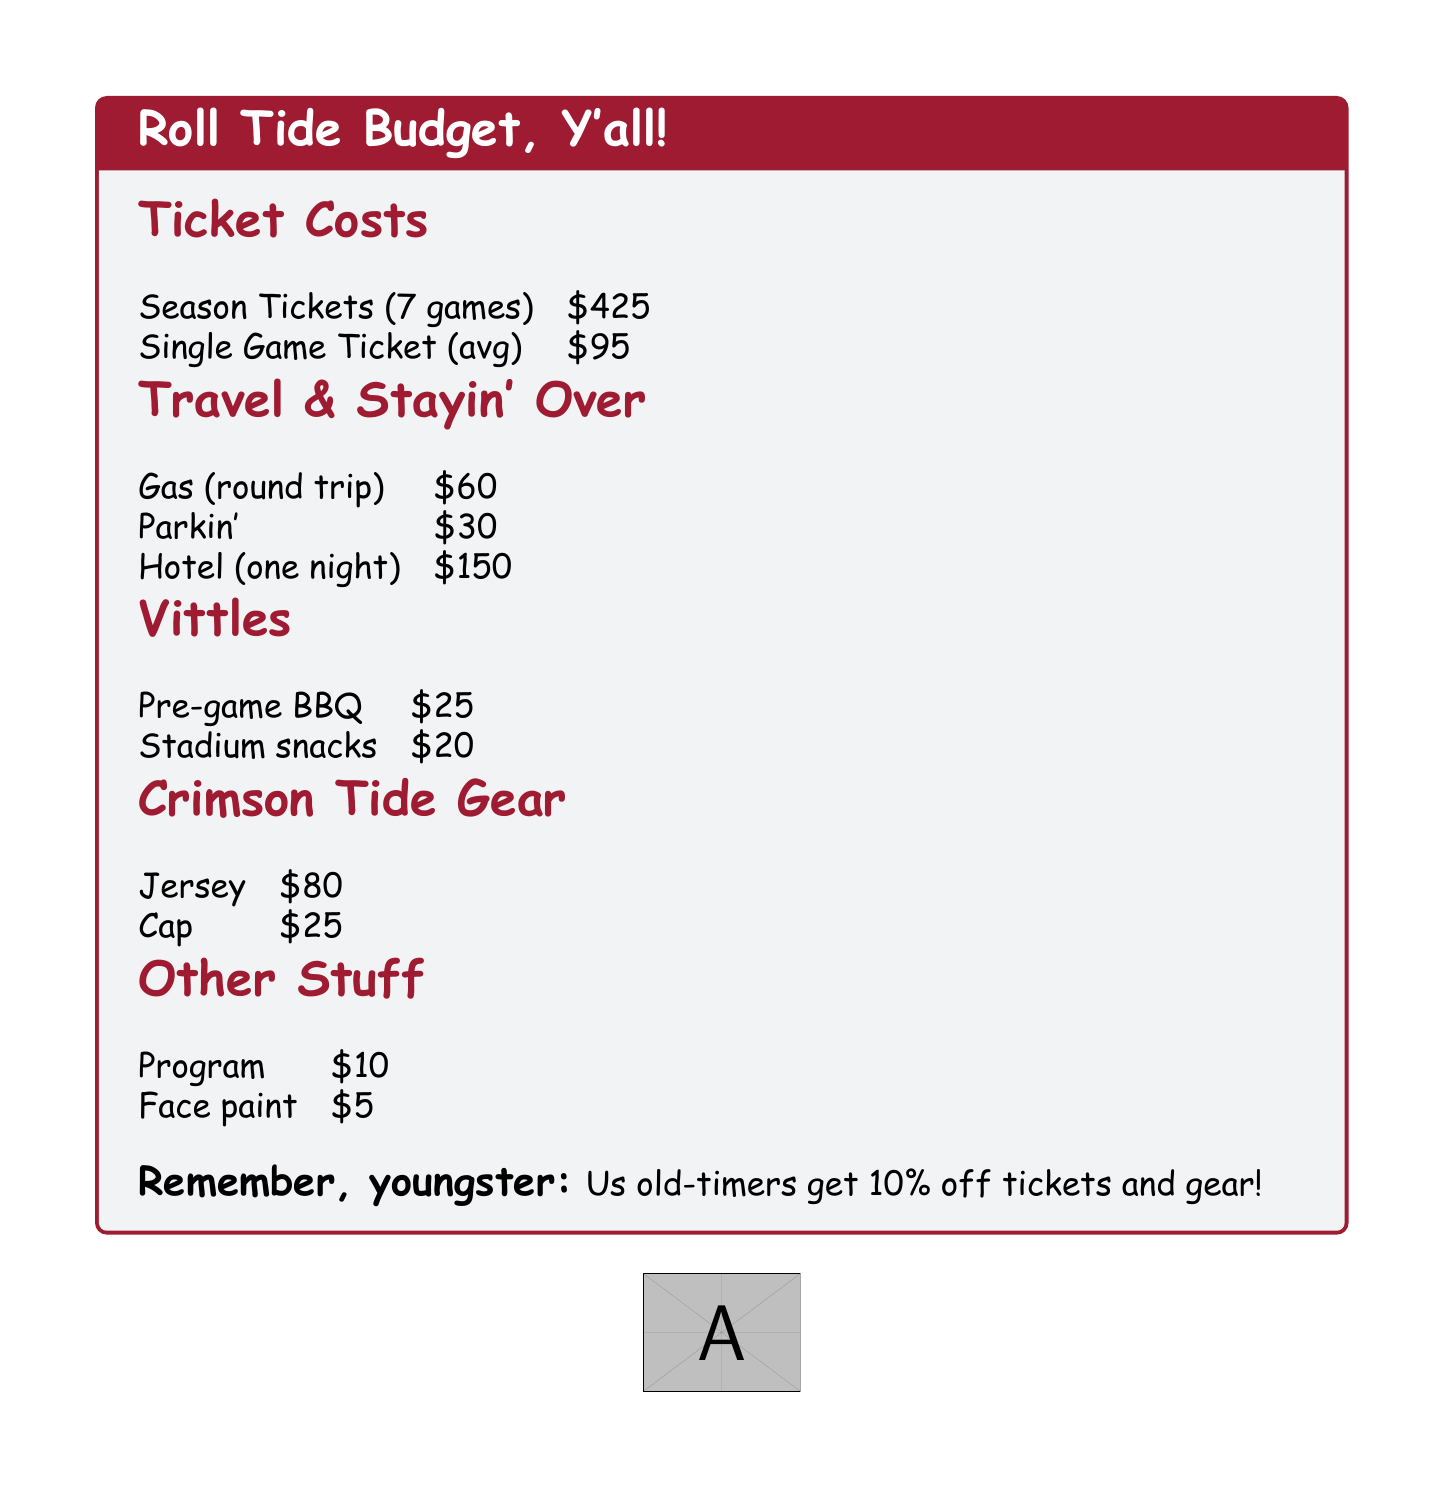What is the cost of season tickets? The cost of season tickets for 7 games is specified in the document.
Answer: $425 How much does a single game ticket cost on average? The document states the average cost of a single game ticket.
Answer: $95 What is the cost for gas for a round trip? The document provides the expense for gas for a round trip to the games.
Answer: $60 What is the price for pre-game BBQ? The document lists the cost for pre-game BBQ as part of the food expenses.
Answer: $25 How much does a hotel stay (one night) cost? The document mentions the price for staying one night in a hotel.
Answer: $150 What is the total cost of attending one game (tickets, travel, food, and gear) if you include a jersey? You must add together the costs provided, including a ticket, travel, food, and a jersey.
Answer: $425 + $60 + $25 + $80 = $590 What percentage discount do old-timers receive on tickets and gear? The document reminds us that old-timers get a discount on certain items.
Answer: 10% What is the total cost of stadium snacks? The cost of stadium snacks is provided in a dedicated section of the document.
Answer: $20 How much is face paint listed for in the other stuff section? The expense for face paint is included in the other categories specified.
Answer: $5 What is the cost of a cap? The document mentions the price of a cap under Crimson Tide gear.
Answer: $25 